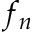<formula> <loc_0><loc_0><loc_500><loc_500>f _ { n }</formula> 